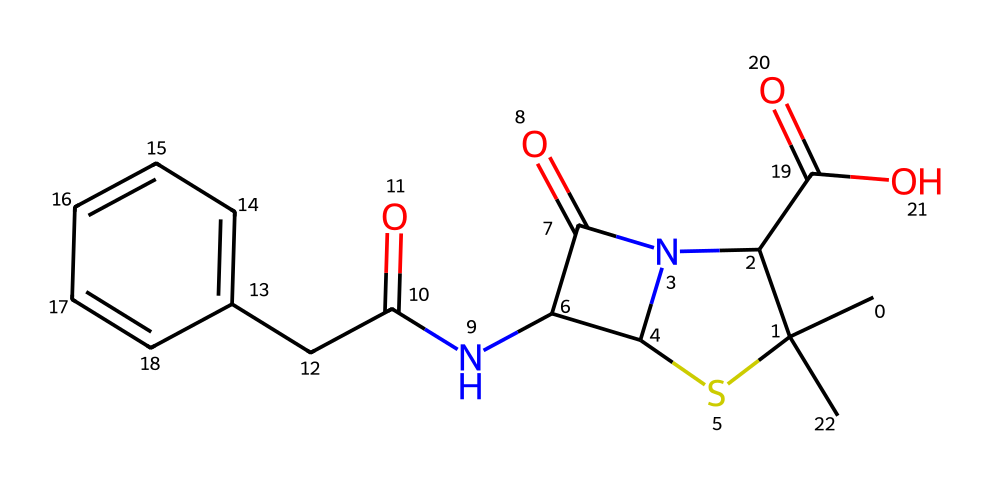what is the molecular formula of penicillin? To determine the molecular formula, we analyze the molecular structure by identifying the types and counts of different atoms present. Looking at the SMILES representation, we can break it down to find that there are carbon (C), hydrogen (H), nitrogen (N), oxygen (O), and sulfur (S) atoms. Counting these gives us C16, H19, N2, O4, S1.
Answer: C16H19N2O4S how many rings are in the molecular structure of penicillin? The structure shows a bicyclic arrangement, which is indicated by the presence of two interconnected ring systems based on the SMILES. Such a ring system reflects how penicillin is structured for its biological activity. By visual inspection or breakdown of the SMILES, we see there are two prominent rings.
Answer: 2 which functional group is responsible for the antibacterial activity of penicillin? The beta-lactam ring, a four-membered cyclic amide structure indicated in the SMILES, is crucial for the antibacterial activity of penicillin. This functional group interacts with bacterial enzymes, inhibiting cell wall synthesis. By identifying this structural motif, we can attribute the primary action of penicillin to this ring.
Answer: beta-lactam what type of bond connects the nitrogen and carbon atoms in penicillin? In penicillin, the bonds between nitrogen and carbon atoms are primarily covalent bonds, as both types of atoms share electrons in this compound. This is determined by recognizing that in organic compounds like penicillin, the carbon-nitrogen linkage will typically be covalent.
Answer: covalent how many nitrogen atoms are present in the penicillin structure? From the SMILES representation, we can count the nitrogen (N) atoms depicted. Scanning through the structure, we identify two nitrogen atoms. This is relevant for understanding the biological function and interaction of the antibiotic with bacterial systems.
Answer: 2 which part of penicillin's structure contributes to its solubility in water? The carboxylic acid group (-COOH) present in penicillin is polar, allowing it to interact favorably with water molecules, thus enhancing its solubility in an aqueous environment. This can be analyzed by recognizing the presence of this functional group from the SMILES representation and its known properties.
Answer: carboxylic acid group 